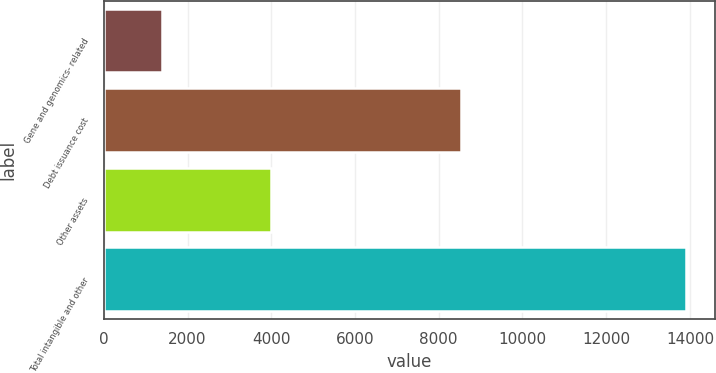Convert chart to OTSL. <chart><loc_0><loc_0><loc_500><loc_500><bar_chart><fcel>Gene and genomics- related<fcel>Debt issuance cost<fcel>Other assets<fcel>Total intangible and other<nl><fcel>1381<fcel>8529<fcel>4000<fcel>13910<nl></chart> 